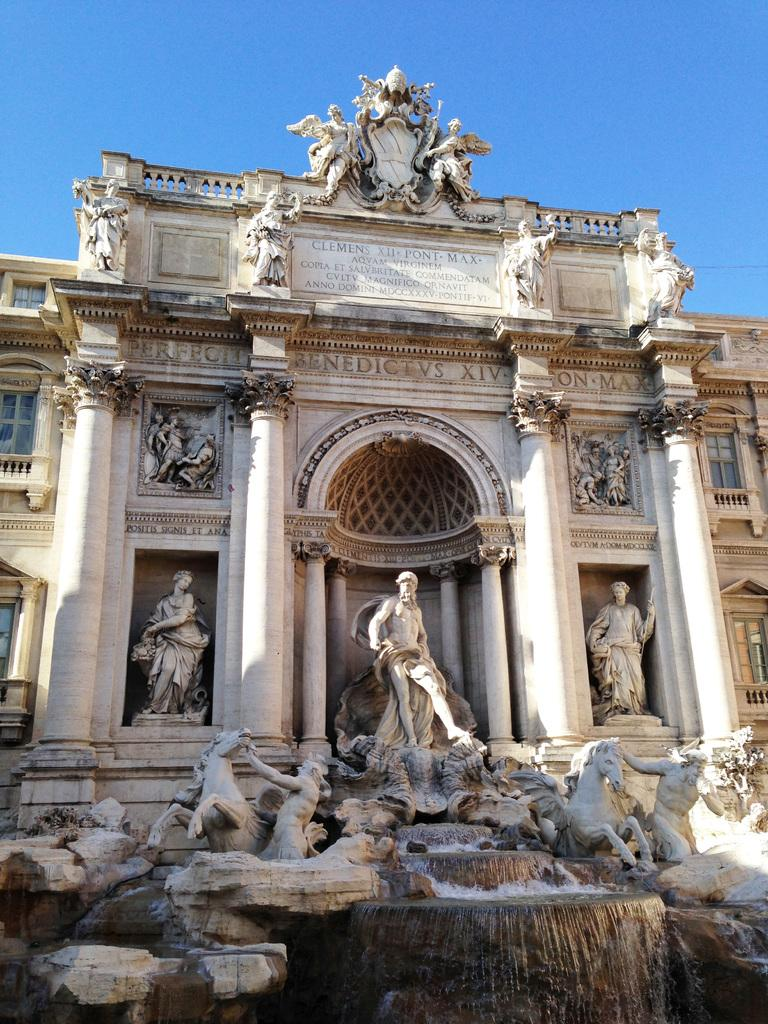What is the main structure in the image? There is a building in the image. Are there any decorative elements on the building? Yes, there are sculptures on the building. What can be seen in the background of the image? The sky is visible in the background of the image. What type of cakes is your dad holding in the image? There is no reference to cakes or your dad in the image, so it is not possible to answer that question. 